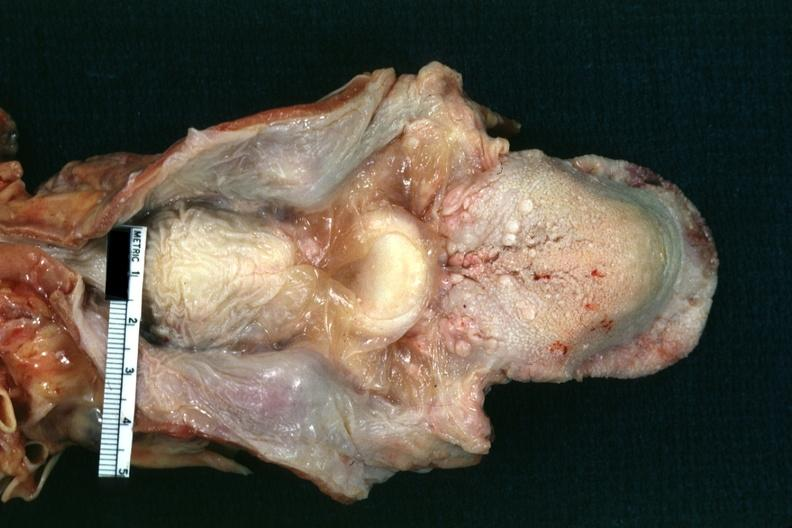what is present?
Answer the question using a single word or phrase. Hypopharyngeal edema 